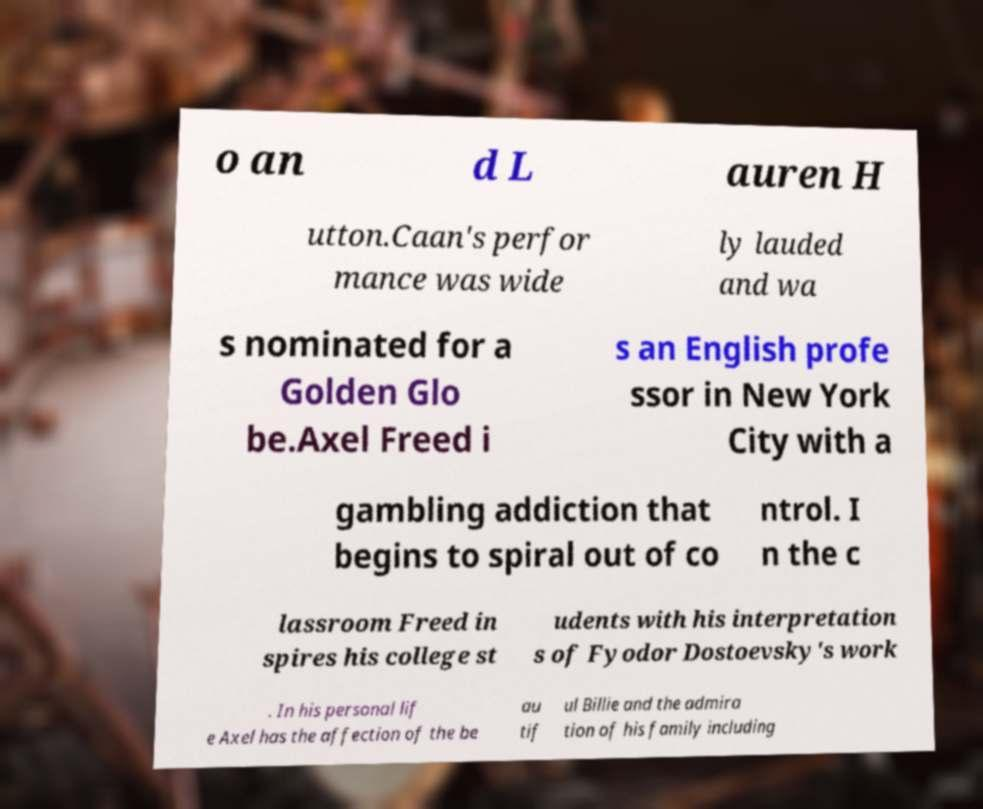Could you extract and type out the text from this image? o an d L auren H utton.Caan's perfor mance was wide ly lauded and wa s nominated for a Golden Glo be.Axel Freed i s an English profe ssor in New York City with a gambling addiction that begins to spiral out of co ntrol. I n the c lassroom Freed in spires his college st udents with his interpretation s of Fyodor Dostoevsky's work . In his personal lif e Axel has the affection of the be au tif ul Billie and the admira tion of his family including 